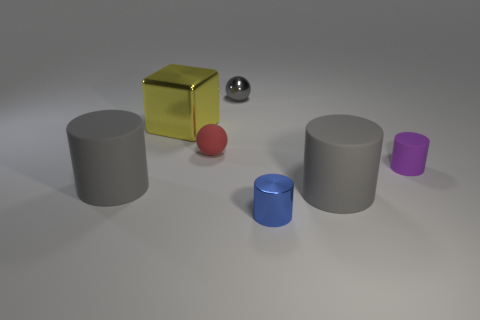Subtract all small matte cylinders. How many cylinders are left? 3 Subtract all cylinders. How many objects are left? 3 Add 1 yellow metallic blocks. How many objects exist? 8 Subtract 1 spheres. How many spheres are left? 1 Subtract all blue cylinders. How many cylinders are left? 3 Subtract all green blocks. Subtract all green cylinders. How many blocks are left? 1 Subtract all purple balls. How many purple cylinders are left? 1 Subtract all red things. Subtract all tiny spheres. How many objects are left? 4 Add 4 small gray metal things. How many small gray metal things are left? 5 Add 3 small gray metallic objects. How many small gray metallic objects exist? 4 